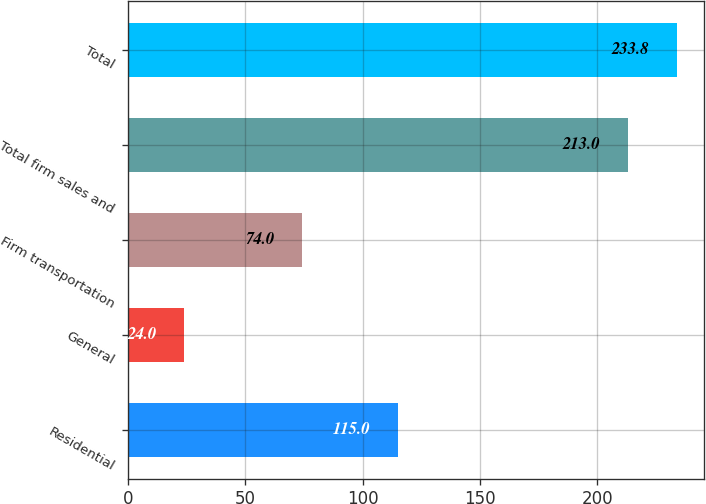<chart> <loc_0><loc_0><loc_500><loc_500><bar_chart><fcel>Residential<fcel>General<fcel>Firm transportation<fcel>Total firm sales and<fcel>Total<nl><fcel>115<fcel>24<fcel>74<fcel>213<fcel>233.8<nl></chart> 